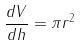<formula> <loc_0><loc_0><loc_500><loc_500>\frac { d V } { d h } = \pi r ^ { 2 }</formula> 